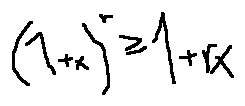Convert formula to latex. <formula><loc_0><loc_0><loc_500><loc_500>( 1 + x ) ^ { r } \geq 1 + r x</formula> 